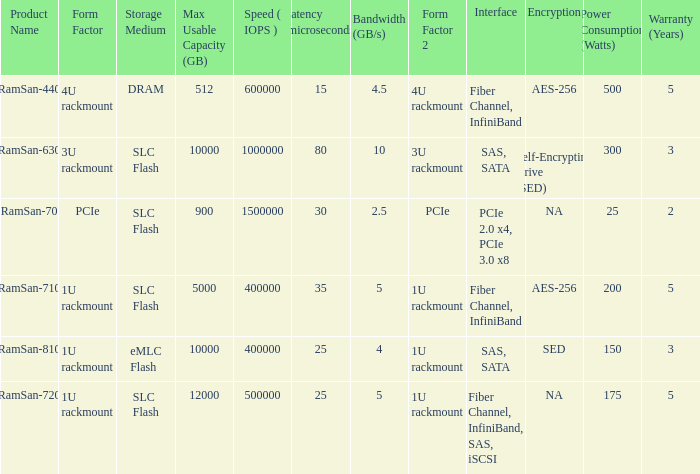What is the ramsan-810 transfer delay? 1.0. 